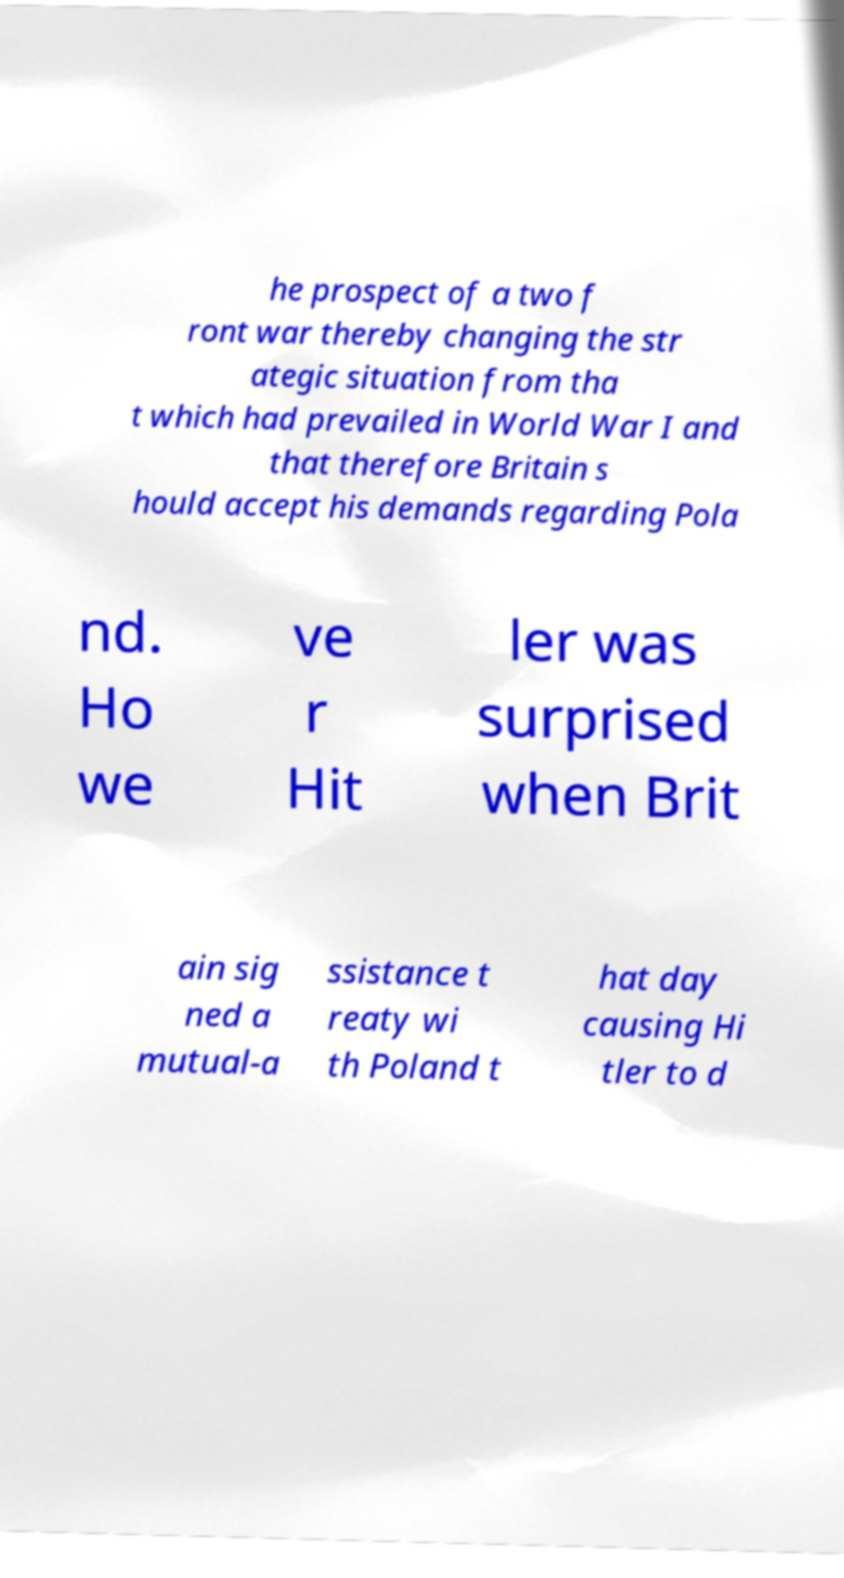What messages or text are displayed in this image? I need them in a readable, typed format. he prospect of a two f ront war thereby changing the str ategic situation from tha t which had prevailed in World War I and that therefore Britain s hould accept his demands regarding Pola nd. Ho we ve r Hit ler was surprised when Brit ain sig ned a mutual-a ssistance t reaty wi th Poland t hat day causing Hi tler to d 